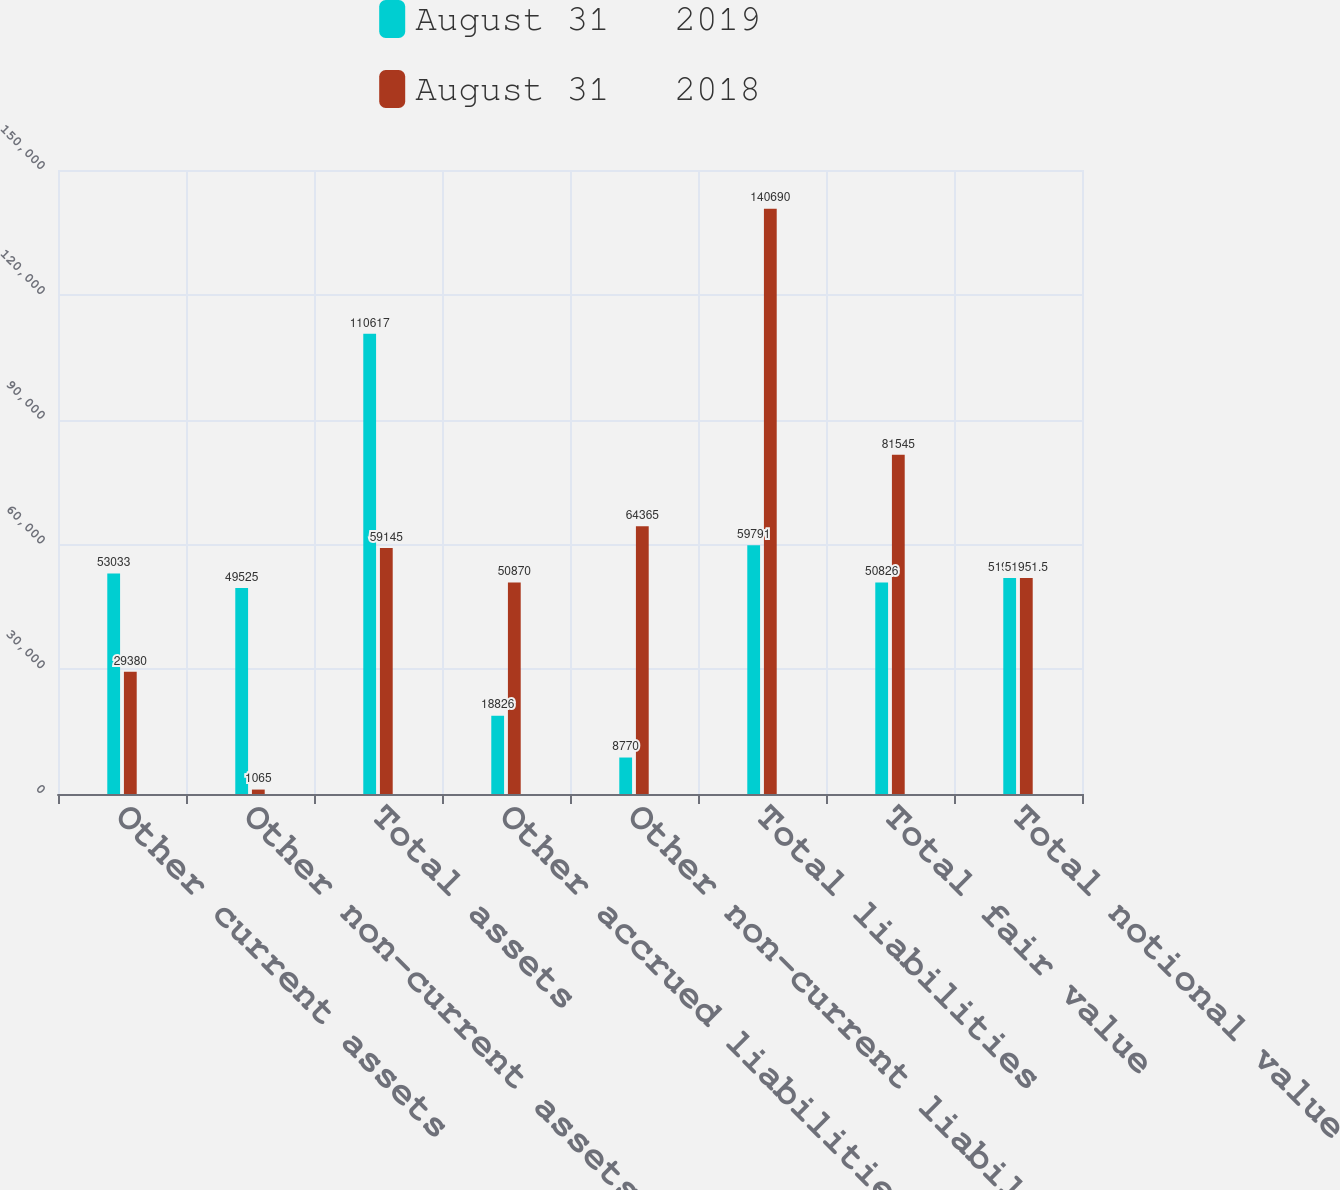<chart> <loc_0><loc_0><loc_500><loc_500><stacked_bar_chart><ecel><fcel>Other current assets<fcel>Other non-current assets<fcel>Total assets<fcel>Other accrued liabilities<fcel>Other non-current liabilities<fcel>Total liabilities<fcel>Total fair value<fcel>Total notional value<nl><fcel>August 31   2019<fcel>53033<fcel>49525<fcel>110617<fcel>18826<fcel>8770<fcel>59791<fcel>50826<fcel>51951.5<nl><fcel>August 31   2018<fcel>29380<fcel>1065<fcel>59145<fcel>50870<fcel>64365<fcel>140690<fcel>81545<fcel>51951.5<nl></chart> 